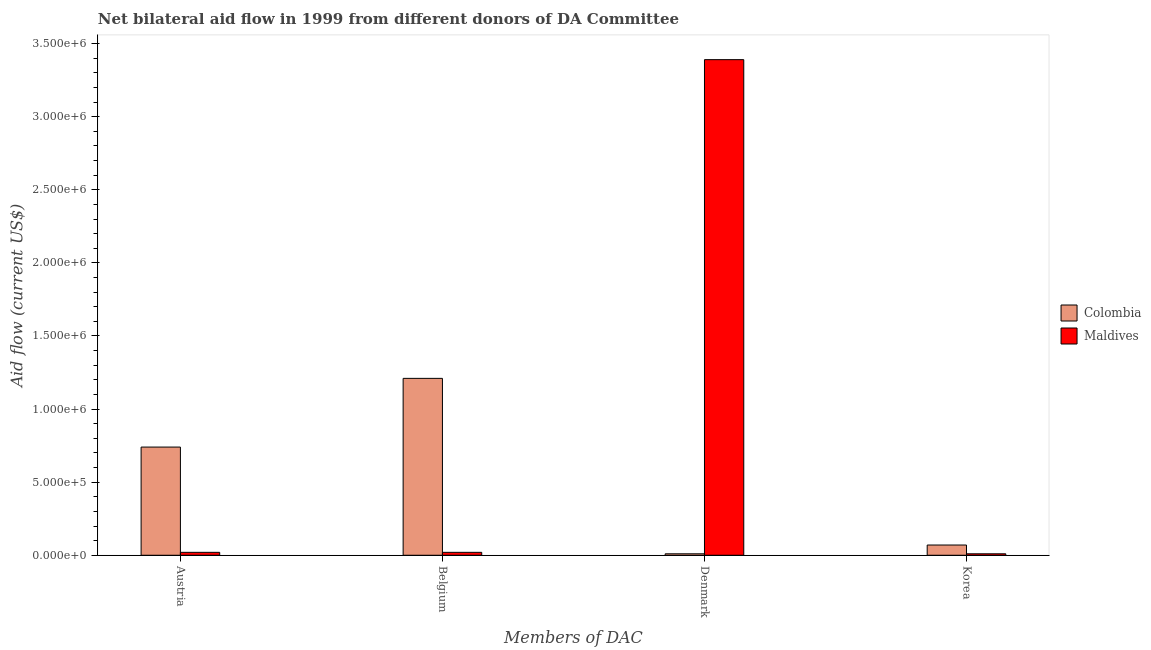Are the number of bars on each tick of the X-axis equal?
Offer a terse response. Yes. What is the amount of aid given by korea in Colombia?
Provide a succinct answer. 7.00e+04. Across all countries, what is the maximum amount of aid given by austria?
Give a very brief answer. 7.40e+05. Across all countries, what is the minimum amount of aid given by korea?
Ensure brevity in your answer.  10000. In which country was the amount of aid given by denmark maximum?
Your answer should be very brief. Maldives. In which country was the amount of aid given by korea minimum?
Ensure brevity in your answer.  Maldives. What is the total amount of aid given by austria in the graph?
Make the answer very short. 7.60e+05. What is the difference between the amount of aid given by austria in Colombia and that in Maldives?
Your answer should be compact. 7.20e+05. What is the difference between the amount of aid given by austria in Maldives and the amount of aid given by belgium in Colombia?
Provide a short and direct response. -1.19e+06. What is the average amount of aid given by korea per country?
Give a very brief answer. 4.00e+04. What is the difference between the amount of aid given by austria and amount of aid given by denmark in Maldives?
Keep it short and to the point. -3.37e+06. In how many countries, is the amount of aid given by belgium greater than 400000 US$?
Make the answer very short. 1. Is the amount of aid given by austria in Colombia less than that in Maldives?
Keep it short and to the point. No. Is the difference between the amount of aid given by denmark in Maldives and Colombia greater than the difference between the amount of aid given by korea in Maldives and Colombia?
Your answer should be compact. Yes. What is the difference between the highest and the second highest amount of aid given by denmark?
Give a very brief answer. 3.38e+06. What is the difference between the highest and the lowest amount of aid given by denmark?
Provide a short and direct response. 3.38e+06. In how many countries, is the amount of aid given by belgium greater than the average amount of aid given by belgium taken over all countries?
Give a very brief answer. 1. Is the sum of the amount of aid given by belgium in Maldives and Colombia greater than the maximum amount of aid given by korea across all countries?
Provide a succinct answer. Yes. Is it the case that in every country, the sum of the amount of aid given by korea and amount of aid given by belgium is greater than the sum of amount of aid given by austria and amount of aid given by denmark?
Your answer should be compact. No. What does the 2nd bar from the left in Korea represents?
Provide a short and direct response. Maldives. How many bars are there?
Give a very brief answer. 8. Are all the bars in the graph horizontal?
Keep it short and to the point. No. Are the values on the major ticks of Y-axis written in scientific E-notation?
Offer a very short reply. Yes. Does the graph contain any zero values?
Your answer should be very brief. No. Does the graph contain grids?
Your response must be concise. No. Where does the legend appear in the graph?
Your answer should be compact. Center right. How are the legend labels stacked?
Keep it short and to the point. Vertical. What is the title of the graph?
Your answer should be compact. Net bilateral aid flow in 1999 from different donors of DA Committee. What is the label or title of the X-axis?
Offer a terse response. Members of DAC. What is the Aid flow (current US$) in Colombia in Austria?
Ensure brevity in your answer.  7.40e+05. What is the Aid flow (current US$) in Colombia in Belgium?
Offer a terse response. 1.21e+06. What is the Aid flow (current US$) of Maldives in Belgium?
Ensure brevity in your answer.  2.00e+04. What is the Aid flow (current US$) in Maldives in Denmark?
Offer a very short reply. 3.39e+06. What is the Aid flow (current US$) of Colombia in Korea?
Make the answer very short. 7.00e+04. Across all Members of DAC, what is the maximum Aid flow (current US$) of Colombia?
Ensure brevity in your answer.  1.21e+06. Across all Members of DAC, what is the maximum Aid flow (current US$) in Maldives?
Your response must be concise. 3.39e+06. Across all Members of DAC, what is the minimum Aid flow (current US$) in Colombia?
Ensure brevity in your answer.  10000. What is the total Aid flow (current US$) of Colombia in the graph?
Your answer should be compact. 2.03e+06. What is the total Aid flow (current US$) of Maldives in the graph?
Make the answer very short. 3.44e+06. What is the difference between the Aid flow (current US$) of Colombia in Austria and that in Belgium?
Your answer should be very brief. -4.70e+05. What is the difference between the Aid flow (current US$) of Maldives in Austria and that in Belgium?
Give a very brief answer. 0. What is the difference between the Aid flow (current US$) of Colombia in Austria and that in Denmark?
Your response must be concise. 7.30e+05. What is the difference between the Aid flow (current US$) in Maldives in Austria and that in Denmark?
Make the answer very short. -3.37e+06. What is the difference between the Aid flow (current US$) in Colombia in Austria and that in Korea?
Give a very brief answer. 6.70e+05. What is the difference between the Aid flow (current US$) of Colombia in Belgium and that in Denmark?
Your answer should be very brief. 1.20e+06. What is the difference between the Aid flow (current US$) in Maldives in Belgium and that in Denmark?
Provide a succinct answer. -3.37e+06. What is the difference between the Aid flow (current US$) of Colombia in Belgium and that in Korea?
Ensure brevity in your answer.  1.14e+06. What is the difference between the Aid flow (current US$) of Maldives in Belgium and that in Korea?
Your answer should be compact. 10000. What is the difference between the Aid flow (current US$) in Maldives in Denmark and that in Korea?
Offer a very short reply. 3.38e+06. What is the difference between the Aid flow (current US$) of Colombia in Austria and the Aid flow (current US$) of Maldives in Belgium?
Keep it short and to the point. 7.20e+05. What is the difference between the Aid flow (current US$) in Colombia in Austria and the Aid flow (current US$) in Maldives in Denmark?
Provide a short and direct response. -2.65e+06. What is the difference between the Aid flow (current US$) in Colombia in Austria and the Aid flow (current US$) in Maldives in Korea?
Offer a very short reply. 7.30e+05. What is the difference between the Aid flow (current US$) of Colombia in Belgium and the Aid flow (current US$) of Maldives in Denmark?
Your answer should be compact. -2.18e+06. What is the difference between the Aid flow (current US$) of Colombia in Belgium and the Aid flow (current US$) of Maldives in Korea?
Give a very brief answer. 1.20e+06. What is the average Aid flow (current US$) of Colombia per Members of DAC?
Offer a terse response. 5.08e+05. What is the average Aid flow (current US$) of Maldives per Members of DAC?
Offer a terse response. 8.60e+05. What is the difference between the Aid flow (current US$) in Colombia and Aid flow (current US$) in Maldives in Austria?
Offer a terse response. 7.20e+05. What is the difference between the Aid flow (current US$) of Colombia and Aid flow (current US$) of Maldives in Belgium?
Your answer should be very brief. 1.19e+06. What is the difference between the Aid flow (current US$) in Colombia and Aid flow (current US$) in Maldives in Denmark?
Ensure brevity in your answer.  -3.38e+06. What is the difference between the Aid flow (current US$) of Colombia and Aid flow (current US$) of Maldives in Korea?
Make the answer very short. 6.00e+04. What is the ratio of the Aid flow (current US$) in Colombia in Austria to that in Belgium?
Ensure brevity in your answer.  0.61. What is the ratio of the Aid flow (current US$) of Maldives in Austria to that in Denmark?
Offer a very short reply. 0.01. What is the ratio of the Aid flow (current US$) in Colombia in Austria to that in Korea?
Keep it short and to the point. 10.57. What is the ratio of the Aid flow (current US$) of Maldives in Austria to that in Korea?
Offer a very short reply. 2. What is the ratio of the Aid flow (current US$) in Colombia in Belgium to that in Denmark?
Your answer should be very brief. 121. What is the ratio of the Aid flow (current US$) in Maldives in Belgium to that in Denmark?
Give a very brief answer. 0.01. What is the ratio of the Aid flow (current US$) in Colombia in Belgium to that in Korea?
Provide a short and direct response. 17.29. What is the ratio of the Aid flow (current US$) in Colombia in Denmark to that in Korea?
Your response must be concise. 0.14. What is the ratio of the Aid flow (current US$) of Maldives in Denmark to that in Korea?
Provide a succinct answer. 339. What is the difference between the highest and the second highest Aid flow (current US$) in Colombia?
Provide a succinct answer. 4.70e+05. What is the difference between the highest and the second highest Aid flow (current US$) of Maldives?
Ensure brevity in your answer.  3.37e+06. What is the difference between the highest and the lowest Aid flow (current US$) in Colombia?
Provide a succinct answer. 1.20e+06. What is the difference between the highest and the lowest Aid flow (current US$) in Maldives?
Offer a terse response. 3.38e+06. 